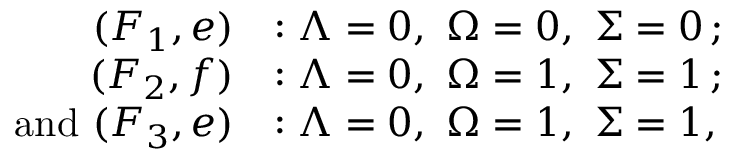Convert formula to latex. <formula><loc_0><loc_0><loc_500><loc_500>\begin{array} { r l } { ( F _ { 1 } , e ) } & { \colon { \Lambda } = 0 , \ { \Omega } = 0 , \ { \Sigma } = 0 \, ; } \\ { ( F _ { 2 } , f ) } & { \colon { \Lambda } = 0 , \ { \Omega } = 1 , \ { \Sigma } = 1 \, ; } \\ { a n d ( F _ { 3 } , e ) } & { \colon { \Lambda } = 0 , \ { \Omega } = 1 , \ { \Sigma } = 1 , } \end{array}</formula> 